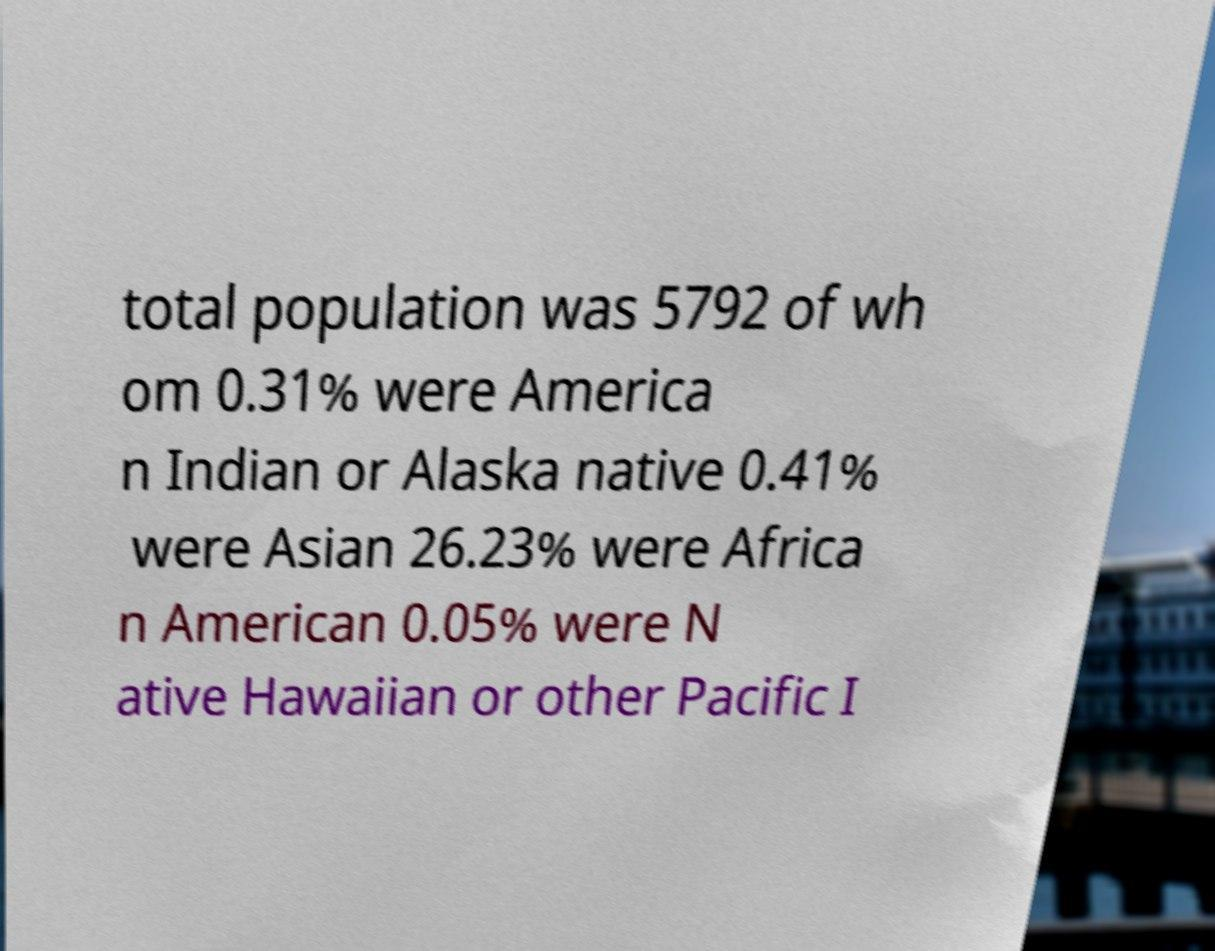For documentation purposes, I need the text within this image transcribed. Could you provide that? total population was 5792 of wh om 0.31% were America n Indian or Alaska native 0.41% were Asian 26.23% were Africa n American 0.05% were N ative Hawaiian or other Pacific I 